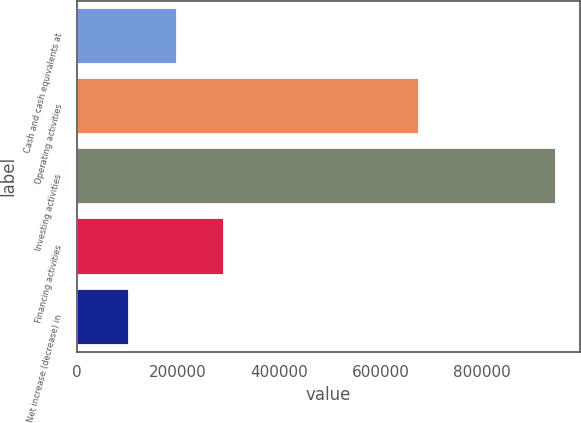<chart> <loc_0><loc_0><loc_500><loc_500><bar_chart><fcel>Cash and cash equivalents at<fcel>Operating activities<fcel>Investing activities<fcel>Financing activities<fcel>Net increase (decrease) in<nl><fcel>196907<fcel>676511<fcel>947995<fcel>290793<fcel>103021<nl></chart> 